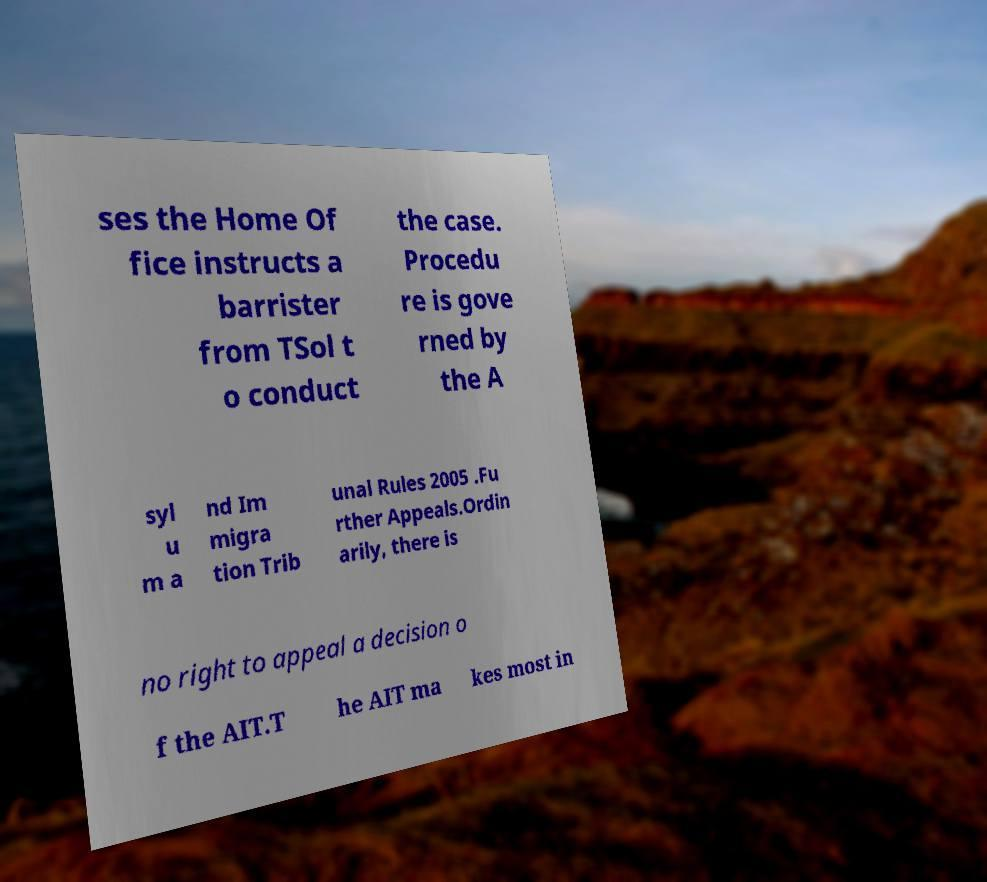Could you extract and type out the text from this image? ses the Home Of fice instructs a barrister from TSol t o conduct the case. Procedu re is gove rned by the A syl u m a nd Im migra tion Trib unal Rules 2005 .Fu rther Appeals.Ordin arily, there is no right to appeal a decision o f the AIT.T he AIT ma kes most in 